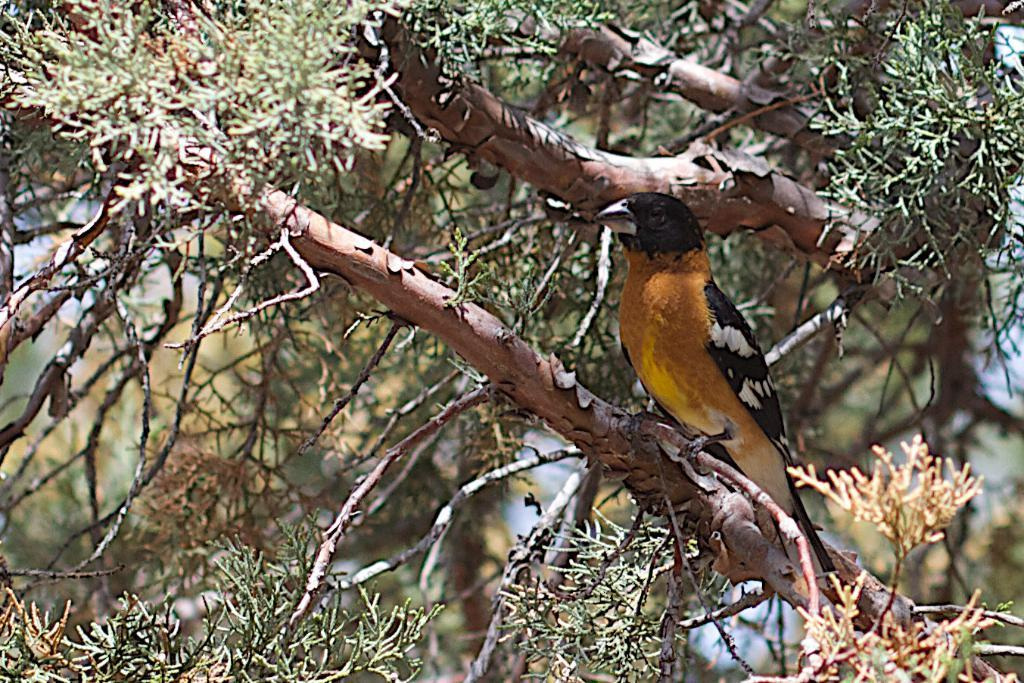What type of animal can be seen in the image? There is a bird in the image. Where is the bird located? The bird is on a tree. Can you describe the background of the image? The background of the image is blurred. What type of knowledge can be gained from the bird's bit in the image? There is no bit or knowledge gained from the bird in the image; it is simply a bird sitting on a tree. 